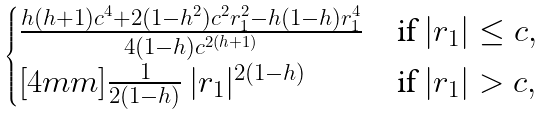Convert formula to latex. <formula><loc_0><loc_0><loc_500><loc_500>\begin{cases} \frac { h ( h + 1 ) c ^ { 4 } + 2 ( 1 - h ^ { 2 } ) c ^ { 2 } r _ { 1 } ^ { 2 } - h ( 1 - h ) r _ { 1 } ^ { 4 } } { 4 ( 1 - h ) c ^ { 2 ( h + 1 ) } } & \text {if $| r_{1}|\leq c$} , \\ [ 4 m m ] \frac { 1 } { 2 ( 1 - h ) } \, | r _ { 1 } | ^ { 2 ( 1 - h ) } & \text {if $| r_{1}|> c$} , \end{cases}</formula> 